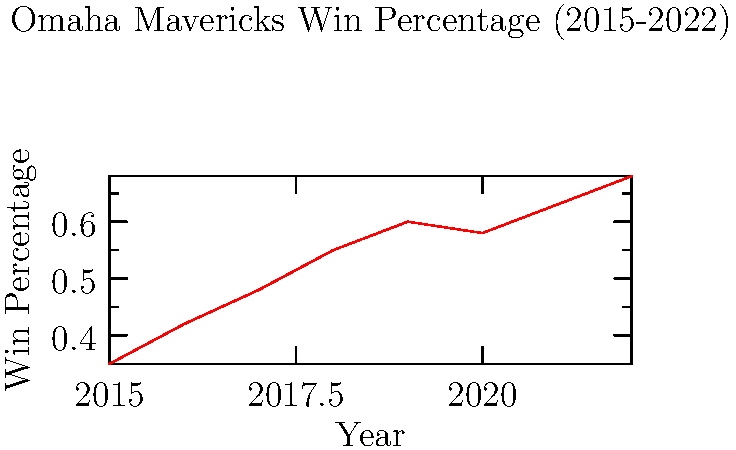Analyze the trend in the Omaha Mavericks' win percentage from 2015 to 2022. Calculate the average annual increase in win percentage and predict the win percentage for 2023 if this trend continues. 1. Observe the overall trend: The graph shows a generally increasing trend from 2015 to 2022.

2. Calculate total increase:
   2022 win percentage: 0.68
   2015 win percentage: 0.35
   Total increase: 0.68 - 0.35 = 0.33

3. Calculate the number of years: 2022 - 2015 = 7 years

4. Calculate average annual increase:
   Average annual increase = Total increase / Number of years
   $\frac{0.33}{7} = 0.0471$ or approximately 4.71% per year

5. Predict 2023 win percentage:
   2022 win percentage: 0.68
   Add average annual increase: 0.68 + 0.0471 = 0.7271

Therefore, if the trend continues, the predicted win percentage for 2023 would be approximately 0.7271 or 72.71%.
Answer: 4.71% average annual increase; 72.71% predicted win percentage for 2023 